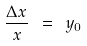<formula> <loc_0><loc_0><loc_500><loc_500>\frac { { \Delta } x } { x } \ = \ y _ { 0 }</formula> 